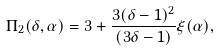<formula> <loc_0><loc_0><loc_500><loc_500>\Pi _ { 2 } ( \delta , \alpha ) = 3 + \frac { 3 ( \delta - 1 ) ^ { 2 } } { ( 3 \delta - 1 ) } \xi ( \alpha ) ,</formula> 